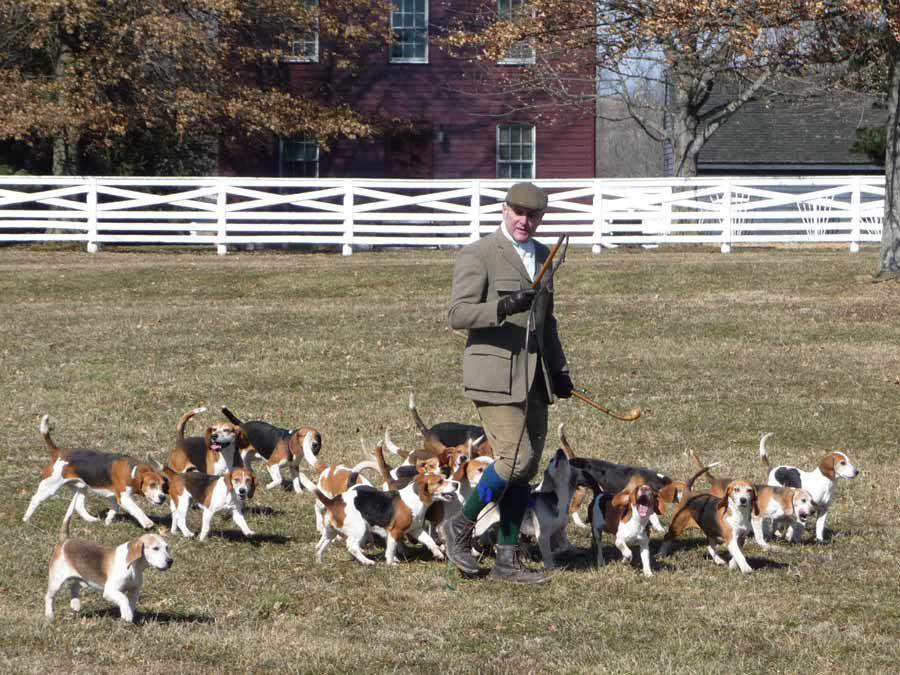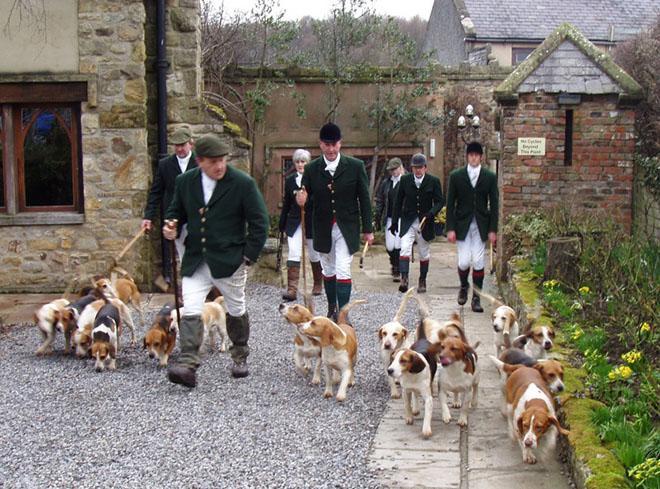The first image is the image on the left, the second image is the image on the right. For the images shown, is this caption "All images contain at least one man in a hat." true? Answer yes or no. Yes. 